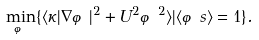Convert formula to latex. <formula><loc_0><loc_0><loc_500><loc_500>\min _ { \varphi } \{ \langle \kappa | \nabla \varphi | ^ { 2 } + U ^ { 2 } \varphi ^ { 2 } \rangle | \langle \varphi s \rangle = 1 \} .</formula> 